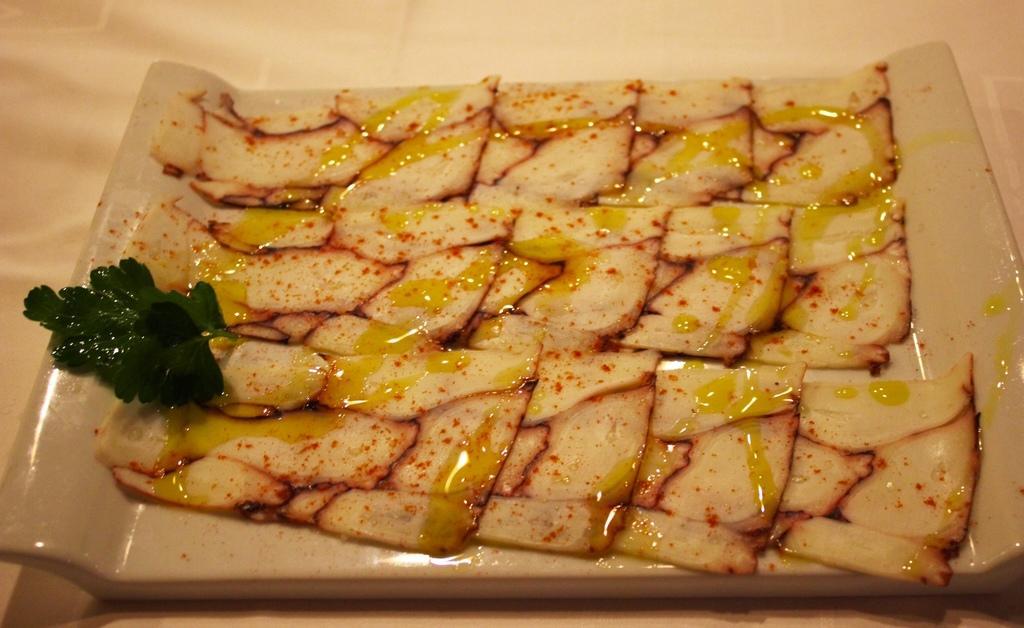In one or two sentences, can you explain what this image depicts? In this image there are some food items on a tray. 